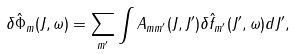Convert formula to latex. <formula><loc_0><loc_0><loc_500><loc_500>\delta \hat { \Phi } _ { m } ( J , \omega ) = \sum _ { m ^ { \prime } } \int A _ { m m ^ { \prime } } ( J , J ^ { \prime } ) \delta \hat { f } _ { m ^ { \prime } } ( J ^ { \prime } , \omega ) d J ^ { \prime } ,</formula> 